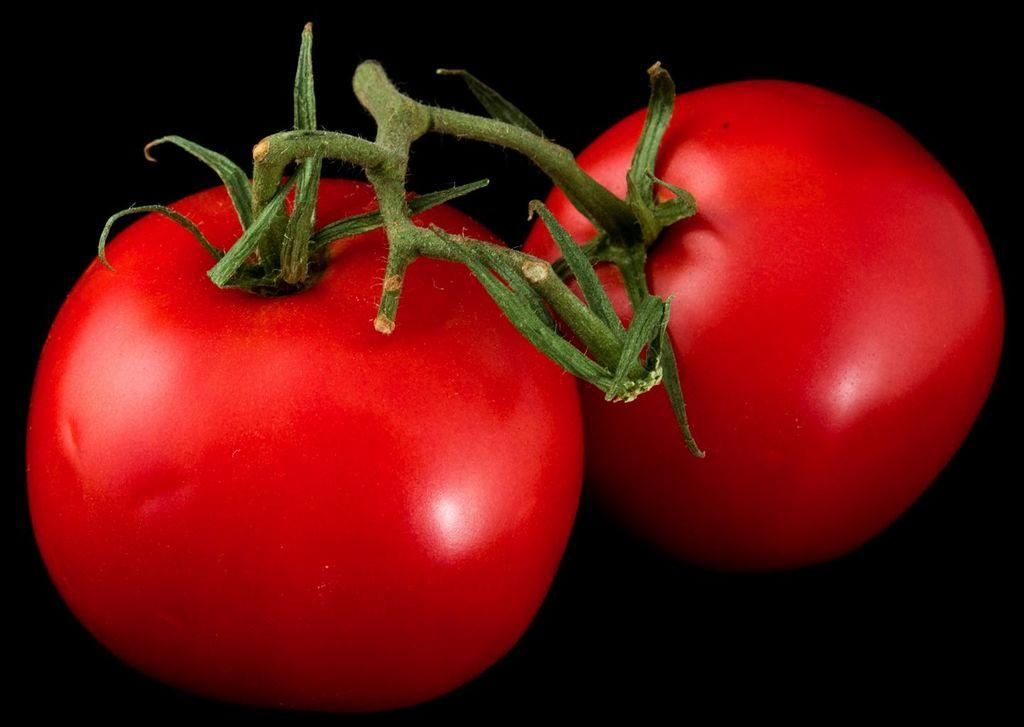What type of fruit is present in the image? There are two tomatoes in the image. What color are the tomatoes? The tomatoes are red in color. What part of the tomato is visible in the image? There are sepals on the tomatoes. What color are the sepals? The sepals are green in color. What is the background color of the image? The background of the image is black. How much money is the tomato shop owner giving to his father in the image? There is no money, shop, or father present in the image; it only features two tomatoes with sepals against a black background. 